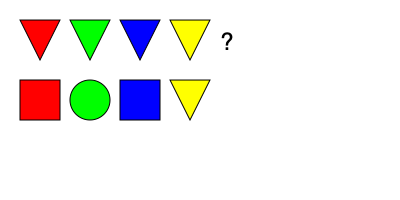Based on the pattern of traditional Romanian folk art motifs shown, what shape should replace the question mark? To solve this pattern recognition question, let's analyze the sequence of shapes and colors:

1. First row (from left to right):
   - Red triangle
   - Green triangle
   - Blue triangle
   - Yellow triangle

2. Second row (from left to right):
   - Red square
   - Green circle
   - Blue square
   - Yellow triangle

3. Observing the pattern:
   - The colors repeat in the same order: red, green, blue, yellow
   - The shapes alternate between the first and second row
   - For red: triangle becomes square
   - For green: triangle becomes circle
   - For blue: triangle becomes square
   - For yellow: triangle remains triangle

4. Following this pattern, the next shape should correspond to the red motif
   - In the first row, red is represented by a triangle
   - In the second row, the triangle became a square

5. Therefore, to continue the pattern, the red triangle should become a square in the next position

This pattern recognition is based on the common repetition and alternation of shapes and colors found in traditional Romanian folk art motifs, which often feature geometric shapes and vibrant colors.
Answer: Red square 